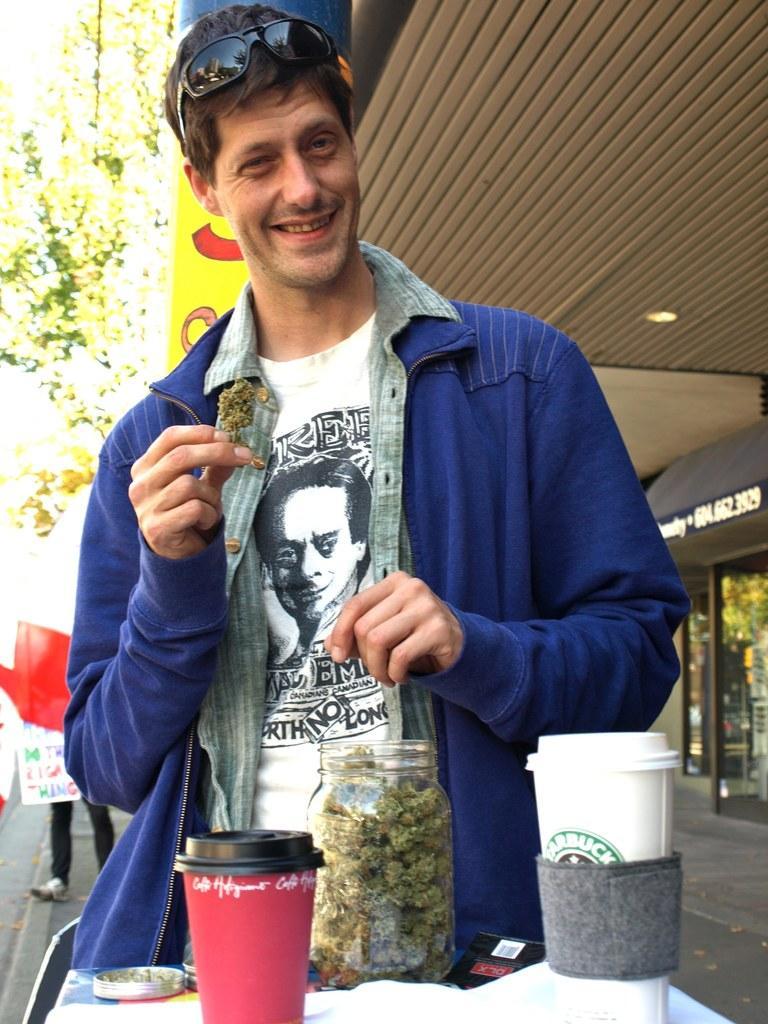Describe this image in one or two sentences. In this image there is a man in the middle who is standing on the floor by holding an object in his hand. In front of him there is a table on which there are two cups and a glass jar. Behind him there are trees. On the right side it seems like a door. At the top there is ceiling with the light. On the left side bottom there is another person standing on the footpath. 